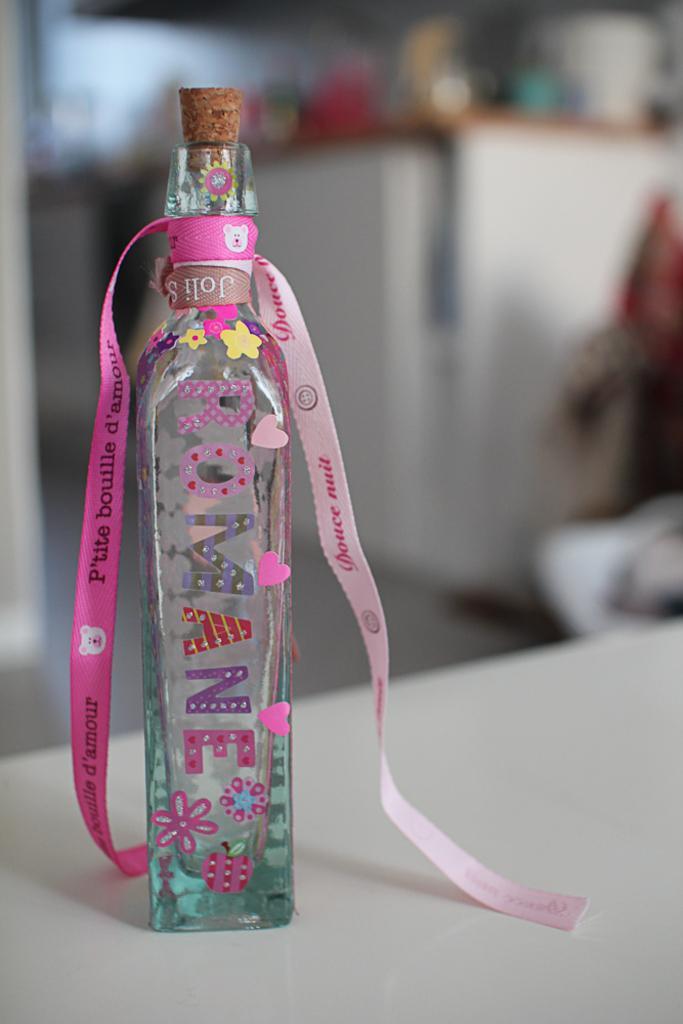In one or two sentences, can you explain what this image depicts? In this picture a glass bottle is decorated with a ribbon and stickers. The bottle is on a white table background of this bottle is blue due to the bottle is focused in this image. 